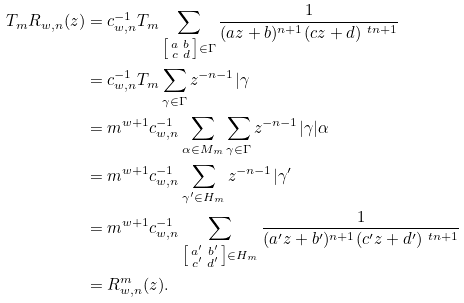<formula> <loc_0><loc_0><loc_500><loc_500>T _ { m } R _ { w , n } ( z ) & = c _ { w , n } ^ { - 1 } T _ { m } \sum _ { \substack { \left [ \begin{smallmatrix} a & b \\ c & d \end{smallmatrix} \right ] \in \Gamma } } \frac { 1 } { ( a z + b ) ^ { n + 1 } ( c z + d ) ^ { \ t n + 1 } } \\ & = c _ { w , n } ^ { - 1 } T _ { m } \sum _ { \gamma \in \Gamma } z ^ { - n - 1 } | \gamma \\ & = m ^ { w + 1 } c _ { w , n } ^ { - 1 } \sum _ { \alpha \in M _ { m } } \sum _ { \gamma \in \Gamma } z ^ { - n - 1 } | \gamma | \alpha \\ & = m ^ { w + 1 } c _ { w , n } ^ { - 1 } \sum _ { \gamma ^ { \prime } \in H _ { m } } z ^ { - n - 1 } | \gamma ^ { \prime } \\ & = m ^ { w + 1 } c _ { w , n } ^ { - 1 } \sum _ { \substack { \left [ \begin{smallmatrix} a ^ { \prime } & b ^ { \prime } \\ c ^ { \prime } & d ^ { \prime } \end{smallmatrix} \right ] \in H _ { m } } } \frac { 1 } { ( a ^ { \prime } z + b ^ { \prime } ) ^ { n + 1 } ( c ^ { \prime } z + d ^ { \prime } ) ^ { \ t n + 1 } } \\ & = R _ { w , n } ^ { m } ( z ) .</formula> 